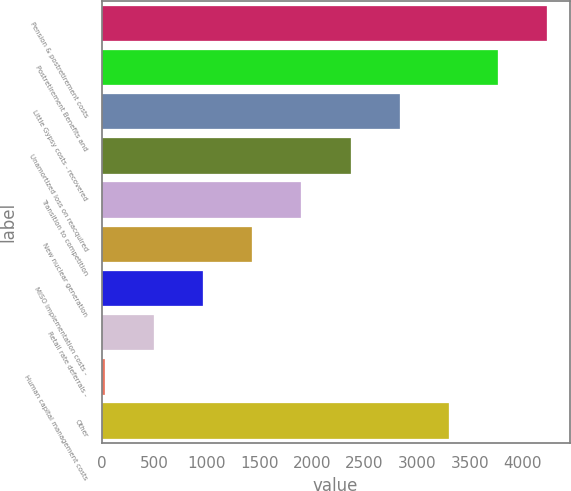Convert chart. <chart><loc_0><loc_0><loc_500><loc_500><bar_chart><fcel>Pension & postretirement costs<fcel>Postretirement Benefits and<fcel>Little Gypsy costs - recovered<fcel>Unamortized loss on reacquired<fcel>Transition to competition<fcel>New nuclear generation<fcel>MISO implementation costs -<fcel>Retail rate deferrals -<fcel>Human capital management costs<fcel>Other<nl><fcel>4237.15<fcel>3769.5<fcel>2834.2<fcel>2366.55<fcel>1898.9<fcel>1431.25<fcel>963.6<fcel>495.95<fcel>28.3<fcel>3301.85<nl></chart> 